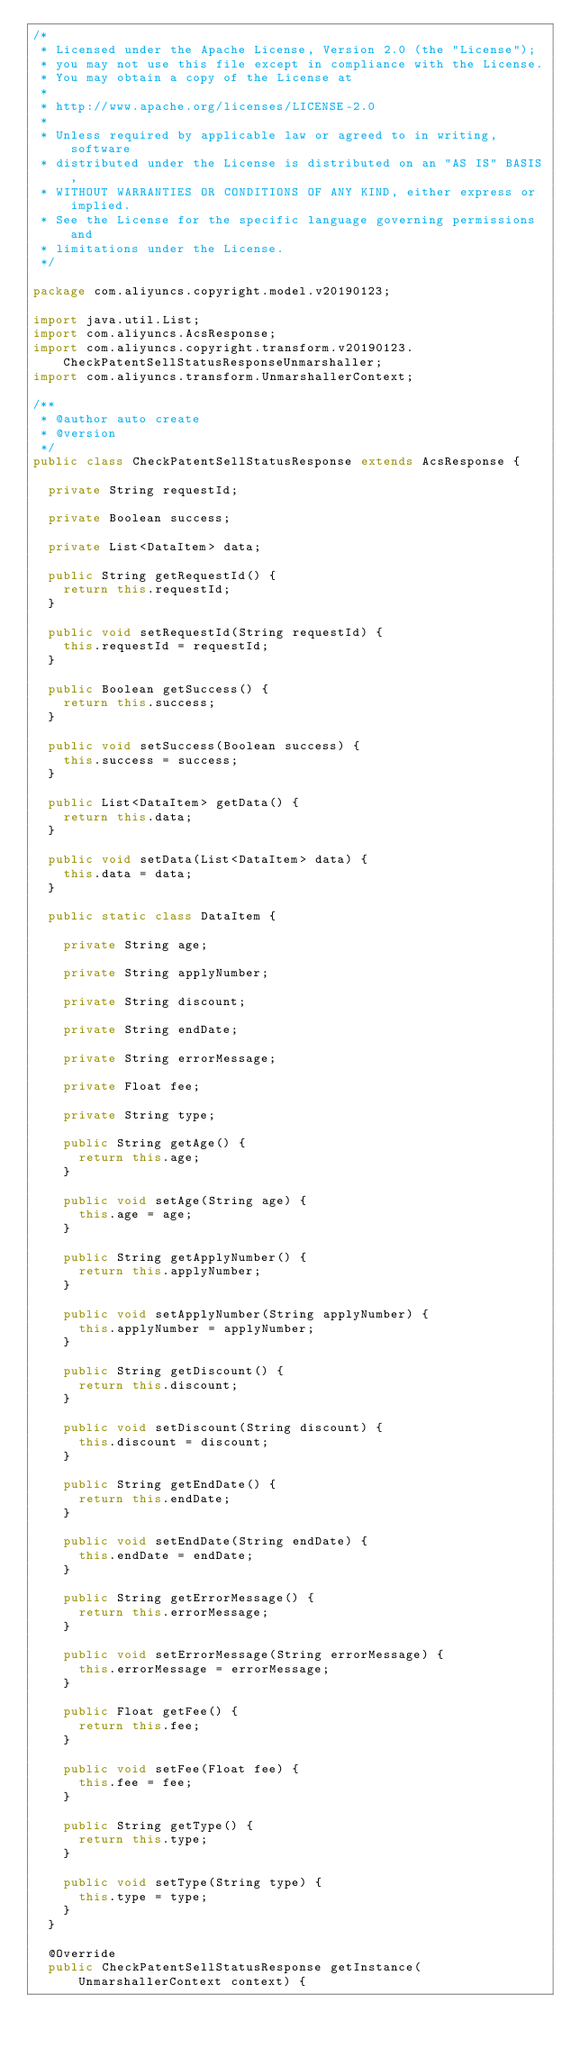<code> <loc_0><loc_0><loc_500><loc_500><_Java_>/*
 * Licensed under the Apache License, Version 2.0 (the "License");
 * you may not use this file except in compliance with the License.
 * You may obtain a copy of the License at
 *
 * http://www.apache.org/licenses/LICENSE-2.0
 *
 * Unless required by applicable law or agreed to in writing, software
 * distributed under the License is distributed on an "AS IS" BASIS,
 * WITHOUT WARRANTIES OR CONDITIONS OF ANY KIND, either express or implied.
 * See the License for the specific language governing permissions and
 * limitations under the License.
 */

package com.aliyuncs.copyright.model.v20190123;

import java.util.List;
import com.aliyuncs.AcsResponse;
import com.aliyuncs.copyright.transform.v20190123.CheckPatentSellStatusResponseUnmarshaller;
import com.aliyuncs.transform.UnmarshallerContext;

/**
 * @author auto create
 * @version 
 */
public class CheckPatentSellStatusResponse extends AcsResponse {

	private String requestId;

	private Boolean success;

	private List<DataItem> data;

	public String getRequestId() {
		return this.requestId;
	}

	public void setRequestId(String requestId) {
		this.requestId = requestId;
	}

	public Boolean getSuccess() {
		return this.success;
	}

	public void setSuccess(Boolean success) {
		this.success = success;
	}

	public List<DataItem> getData() {
		return this.data;
	}

	public void setData(List<DataItem> data) {
		this.data = data;
	}

	public static class DataItem {

		private String age;

		private String applyNumber;

		private String discount;

		private String endDate;

		private String errorMessage;

		private Float fee;

		private String type;

		public String getAge() {
			return this.age;
		}

		public void setAge(String age) {
			this.age = age;
		}

		public String getApplyNumber() {
			return this.applyNumber;
		}

		public void setApplyNumber(String applyNumber) {
			this.applyNumber = applyNumber;
		}

		public String getDiscount() {
			return this.discount;
		}

		public void setDiscount(String discount) {
			this.discount = discount;
		}

		public String getEndDate() {
			return this.endDate;
		}

		public void setEndDate(String endDate) {
			this.endDate = endDate;
		}

		public String getErrorMessage() {
			return this.errorMessage;
		}

		public void setErrorMessage(String errorMessage) {
			this.errorMessage = errorMessage;
		}

		public Float getFee() {
			return this.fee;
		}

		public void setFee(Float fee) {
			this.fee = fee;
		}

		public String getType() {
			return this.type;
		}

		public void setType(String type) {
			this.type = type;
		}
	}

	@Override
	public CheckPatentSellStatusResponse getInstance(UnmarshallerContext context) {</code> 